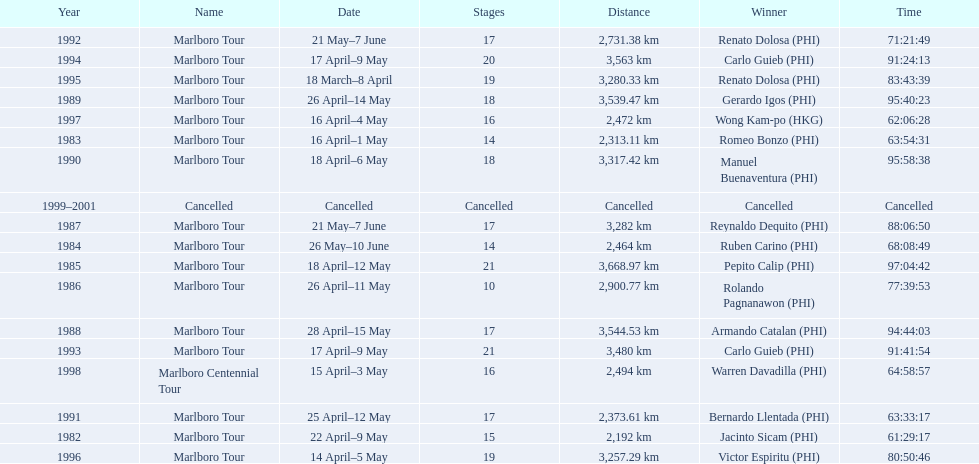What were the tour names during le tour de filipinas? Marlboro Tour, Marlboro Tour, Marlboro Tour, Marlboro Tour, Marlboro Tour, Marlboro Tour, Marlboro Tour, Marlboro Tour, Marlboro Tour, Marlboro Tour, Marlboro Tour, Marlboro Tour, Marlboro Tour, Marlboro Tour, Marlboro Tour, Marlboro Tour, Marlboro Centennial Tour, Cancelled. What were the recorded distances for each marlboro tour? 2,192 km, 2,313.11 km, 2,464 km, 3,668.97 km, 2,900.77 km, 3,282 km, 3,544.53 km, 3,539.47 km, 3,317.42 km, 2,373.61 km, 2,731.38 km, 3,480 km, 3,563 km, 3,280.33 km, 3,257.29 km, 2,472 km. And of those distances, which was the longest? 3,668.97 km. 